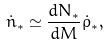Convert formula to latex. <formula><loc_0><loc_0><loc_500><loc_500>\dot { n } _ { * } \simeq \frac { d N _ { * } } { d M } \dot { \rho } _ { * } ,</formula> 